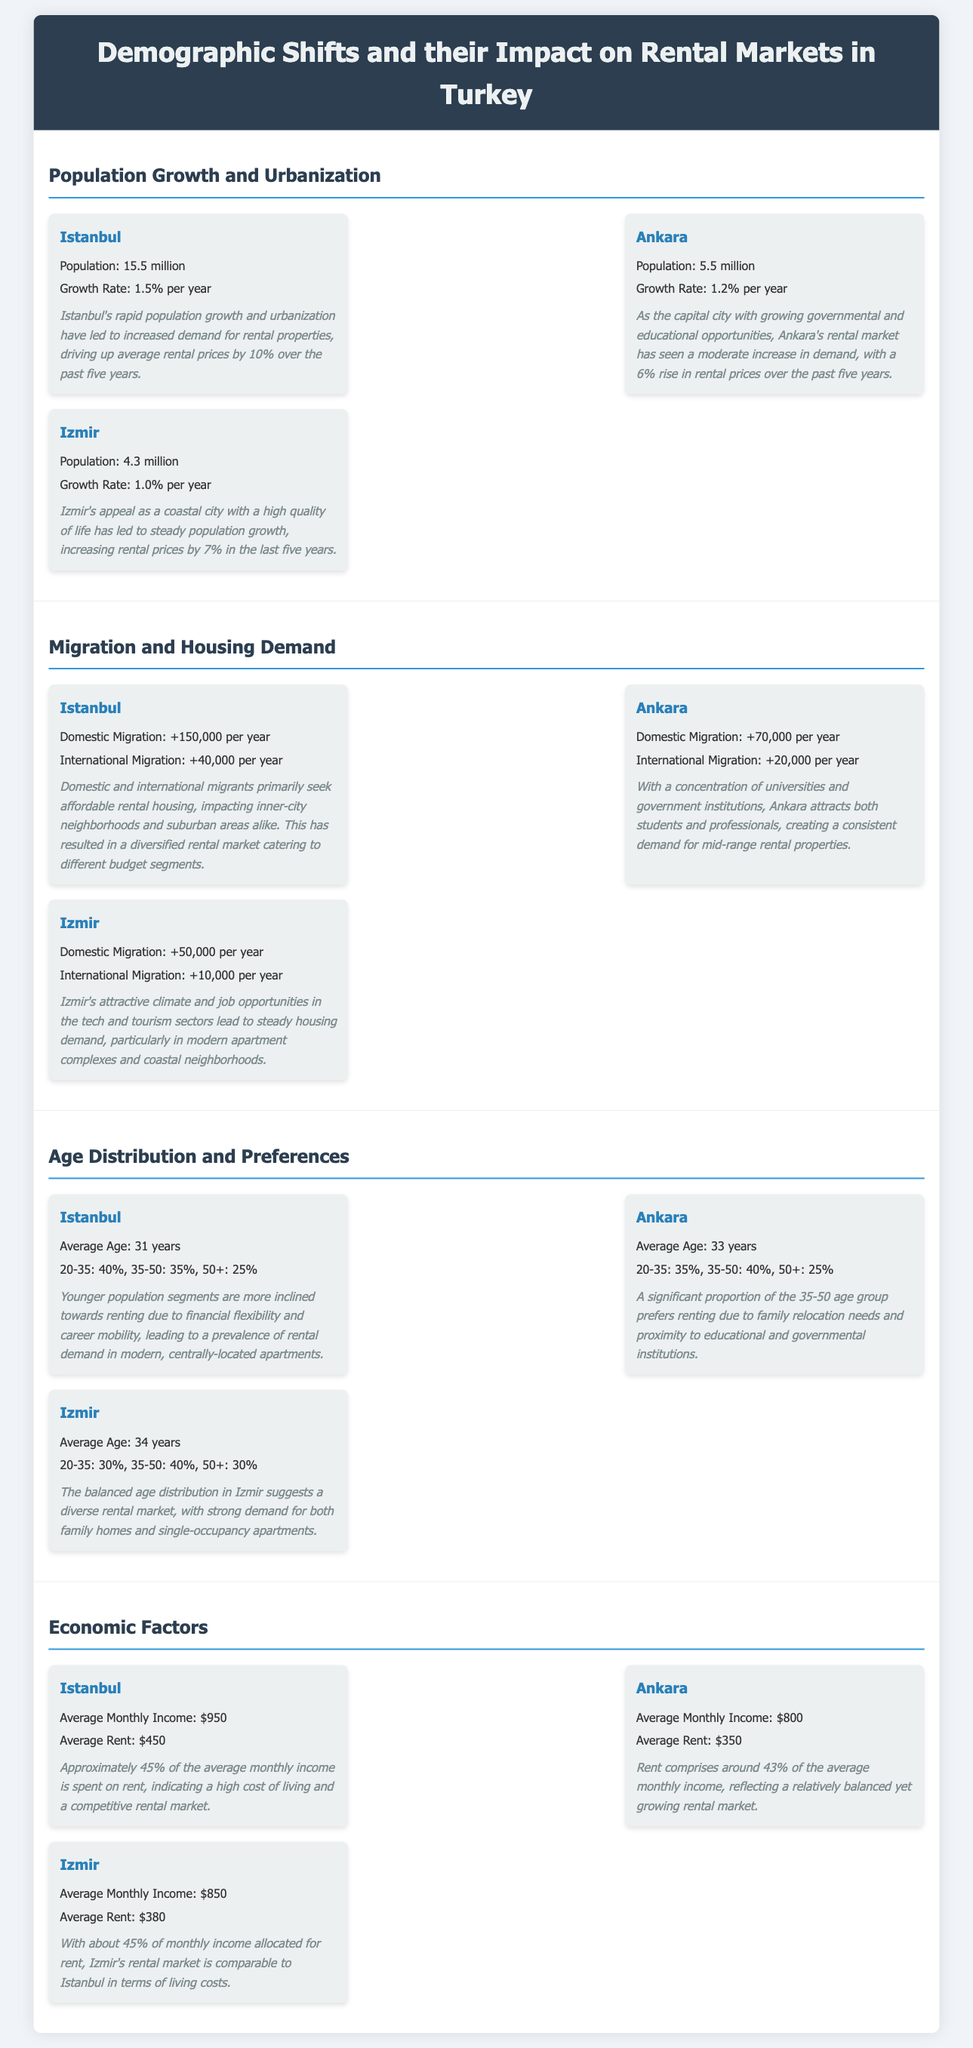What is Istanbul's population? The document states that Istanbul's population is 15.5 million.
Answer: 15.5 million What is the average growth rate of Ankara? The average growth rate mentioned for Ankara is 1.2% per year.
Answer: 1.2% per year How much has Izmir's rental prices increased in the last five years? The document indicates that Izmir's rental prices have increased by 7% in the last five years.
Answer: 7% What percentage of Istanbul's population is aged 20-35? According to the document, 40% of Istanbul's population is aged 20-35.
Answer: 40% What is the average rent in Ankara? The average rent listed for Ankara is $350.
Answer: $350 What is the average monthly income in Istanbul? The document states that the average monthly income in Istanbul is $950.
Answer: $950 Which city has the highest domestic migration per year? The document notes that Istanbul has the highest domestic migration, with +150,000 per year.
Answer: Istanbul How much of an average monthly income is spent on rent in Izmir? The document mentions that approximately 45% of the average monthly income is spent on rent in Izmir.
Answer: 45% What demographic group primarily drives rental demand in Istanbul? The insight suggests that younger population segments drive rental demand in Istanbul.
Answer: Younger population segments 